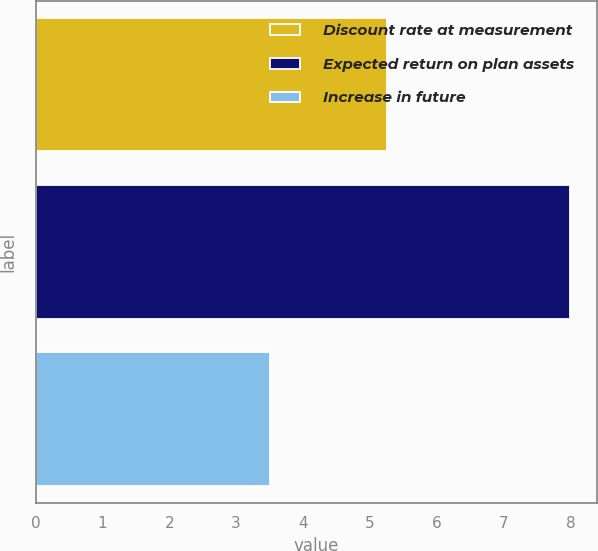<chart> <loc_0><loc_0><loc_500><loc_500><bar_chart><fcel>Discount rate at measurement<fcel>Expected return on plan assets<fcel>Increase in future<nl><fcel>5.25<fcel>8<fcel>3.5<nl></chart> 